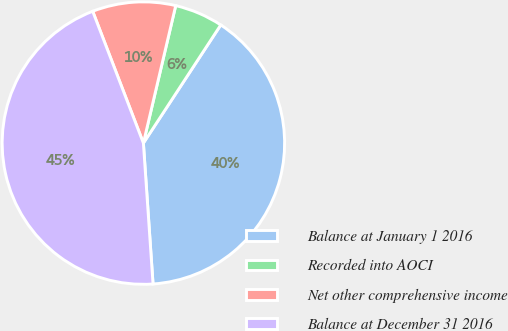Convert chart. <chart><loc_0><loc_0><loc_500><loc_500><pie_chart><fcel>Balance at January 1 2016<fcel>Recorded into AOCI<fcel>Net other comprehensive income<fcel>Balance at December 31 2016<nl><fcel>39.68%<fcel>5.55%<fcel>9.52%<fcel>45.24%<nl></chart> 